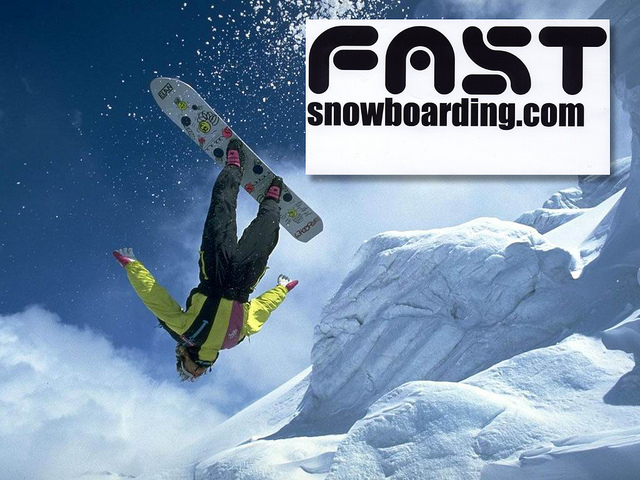Please identify all text content in this image. FAST snowboarding.com 